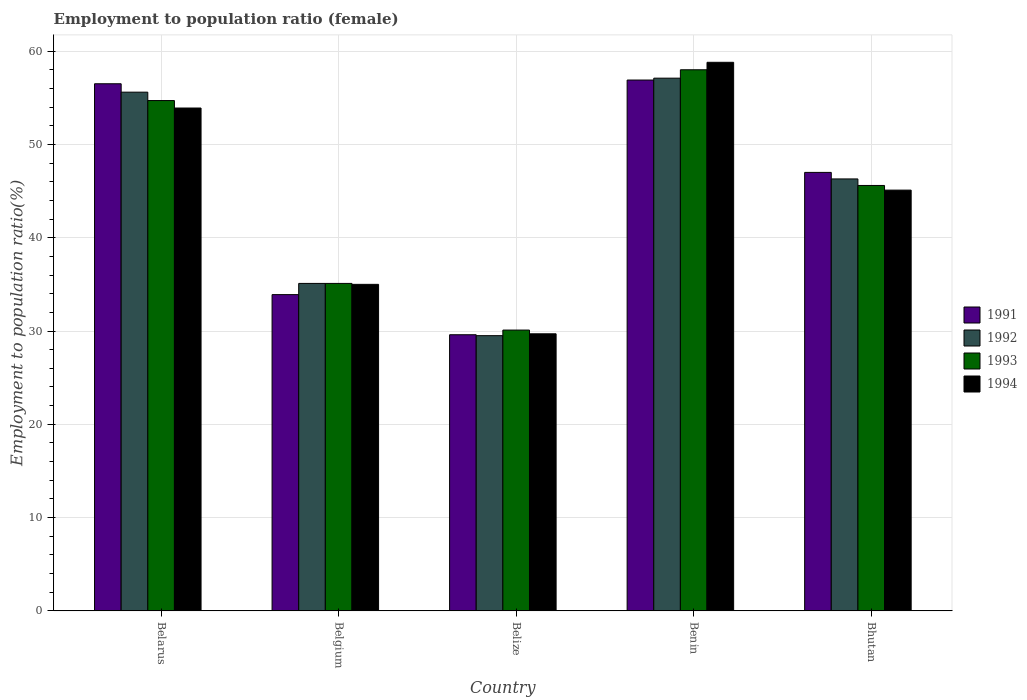How many groups of bars are there?
Offer a terse response. 5. How many bars are there on the 4th tick from the right?
Your answer should be compact. 4. What is the label of the 3rd group of bars from the left?
Provide a short and direct response. Belize. What is the employment to population ratio in 1992 in Belarus?
Ensure brevity in your answer.  55.6. Across all countries, what is the maximum employment to population ratio in 1994?
Offer a terse response. 58.8. Across all countries, what is the minimum employment to population ratio in 1992?
Your answer should be compact. 29.5. In which country was the employment to population ratio in 1991 maximum?
Give a very brief answer. Benin. In which country was the employment to population ratio in 1991 minimum?
Your answer should be compact. Belize. What is the total employment to population ratio in 1993 in the graph?
Offer a very short reply. 223.5. What is the difference between the employment to population ratio in 1992 in Belize and that in Bhutan?
Offer a terse response. -16.8. What is the difference between the employment to population ratio in 1993 in Belize and the employment to population ratio in 1991 in Bhutan?
Provide a succinct answer. -16.9. What is the average employment to population ratio in 1994 per country?
Your response must be concise. 44.5. What is the difference between the employment to population ratio of/in 1991 and employment to population ratio of/in 1992 in Bhutan?
Offer a terse response. 0.7. In how many countries, is the employment to population ratio in 1993 greater than 28 %?
Provide a short and direct response. 5. What is the ratio of the employment to population ratio in 1991 in Benin to that in Bhutan?
Your response must be concise. 1.21. What is the difference between the highest and the second highest employment to population ratio in 1992?
Ensure brevity in your answer.  10.8. What is the difference between the highest and the lowest employment to population ratio in 1992?
Your answer should be very brief. 27.6. In how many countries, is the employment to population ratio in 1991 greater than the average employment to population ratio in 1991 taken over all countries?
Keep it short and to the point. 3. What does the 1st bar from the left in Benin represents?
Give a very brief answer. 1991. What does the 3rd bar from the right in Belize represents?
Offer a very short reply. 1992. Is it the case that in every country, the sum of the employment to population ratio in 1994 and employment to population ratio in 1992 is greater than the employment to population ratio in 1993?
Offer a terse response. Yes. How many bars are there?
Offer a very short reply. 20. How many countries are there in the graph?
Keep it short and to the point. 5. What is the difference between two consecutive major ticks on the Y-axis?
Give a very brief answer. 10. Are the values on the major ticks of Y-axis written in scientific E-notation?
Your answer should be very brief. No. Does the graph contain any zero values?
Offer a terse response. No. How are the legend labels stacked?
Provide a short and direct response. Vertical. What is the title of the graph?
Your answer should be compact. Employment to population ratio (female). What is the label or title of the X-axis?
Give a very brief answer. Country. What is the Employment to population ratio(%) of 1991 in Belarus?
Your response must be concise. 56.5. What is the Employment to population ratio(%) in 1992 in Belarus?
Provide a succinct answer. 55.6. What is the Employment to population ratio(%) in 1993 in Belarus?
Your response must be concise. 54.7. What is the Employment to population ratio(%) in 1994 in Belarus?
Your response must be concise. 53.9. What is the Employment to population ratio(%) of 1991 in Belgium?
Give a very brief answer. 33.9. What is the Employment to population ratio(%) in 1992 in Belgium?
Offer a terse response. 35.1. What is the Employment to population ratio(%) of 1993 in Belgium?
Your answer should be compact. 35.1. What is the Employment to population ratio(%) of 1991 in Belize?
Give a very brief answer. 29.6. What is the Employment to population ratio(%) in 1992 in Belize?
Your answer should be compact. 29.5. What is the Employment to population ratio(%) in 1993 in Belize?
Provide a succinct answer. 30.1. What is the Employment to population ratio(%) in 1994 in Belize?
Keep it short and to the point. 29.7. What is the Employment to population ratio(%) in 1991 in Benin?
Your response must be concise. 56.9. What is the Employment to population ratio(%) of 1992 in Benin?
Your answer should be compact. 57.1. What is the Employment to population ratio(%) of 1994 in Benin?
Give a very brief answer. 58.8. What is the Employment to population ratio(%) of 1991 in Bhutan?
Offer a terse response. 47. What is the Employment to population ratio(%) in 1992 in Bhutan?
Make the answer very short. 46.3. What is the Employment to population ratio(%) in 1993 in Bhutan?
Give a very brief answer. 45.6. What is the Employment to population ratio(%) in 1994 in Bhutan?
Provide a succinct answer. 45.1. Across all countries, what is the maximum Employment to population ratio(%) in 1991?
Offer a terse response. 56.9. Across all countries, what is the maximum Employment to population ratio(%) in 1992?
Give a very brief answer. 57.1. Across all countries, what is the maximum Employment to population ratio(%) in 1994?
Your answer should be compact. 58.8. Across all countries, what is the minimum Employment to population ratio(%) in 1991?
Give a very brief answer. 29.6. Across all countries, what is the minimum Employment to population ratio(%) in 1992?
Offer a very short reply. 29.5. Across all countries, what is the minimum Employment to population ratio(%) of 1993?
Give a very brief answer. 30.1. Across all countries, what is the minimum Employment to population ratio(%) of 1994?
Your answer should be very brief. 29.7. What is the total Employment to population ratio(%) in 1991 in the graph?
Make the answer very short. 223.9. What is the total Employment to population ratio(%) of 1992 in the graph?
Provide a short and direct response. 223.6. What is the total Employment to population ratio(%) of 1993 in the graph?
Offer a very short reply. 223.5. What is the total Employment to population ratio(%) of 1994 in the graph?
Provide a succinct answer. 222.5. What is the difference between the Employment to population ratio(%) in 1991 in Belarus and that in Belgium?
Offer a very short reply. 22.6. What is the difference between the Employment to population ratio(%) of 1993 in Belarus and that in Belgium?
Keep it short and to the point. 19.6. What is the difference between the Employment to population ratio(%) of 1994 in Belarus and that in Belgium?
Keep it short and to the point. 18.9. What is the difference between the Employment to population ratio(%) in 1991 in Belarus and that in Belize?
Provide a succinct answer. 26.9. What is the difference between the Employment to population ratio(%) in 1992 in Belarus and that in Belize?
Ensure brevity in your answer.  26.1. What is the difference between the Employment to population ratio(%) of 1993 in Belarus and that in Belize?
Your answer should be compact. 24.6. What is the difference between the Employment to population ratio(%) in 1994 in Belarus and that in Belize?
Your answer should be compact. 24.2. What is the difference between the Employment to population ratio(%) in 1992 in Belarus and that in Benin?
Your answer should be very brief. -1.5. What is the difference between the Employment to population ratio(%) of 1992 in Belarus and that in Bhutan?
Ensure brevity in your answer.  9.3. What is the difference between the Employment to population ratio(%) of 1993 in Belarus and that in Bhutan?
Offer a very short reply. 9.1. What is the difference between the Employment to population ratio(%) in 1994 in Belarus and that in Bhutan?
Your answer should be very brief. 8.8. What is the difference between the Employment to population ratio(%) in 1991 in Belgium and that in Belize?
Give a very brief answer. 4.3. What is the difference between the Employment to population ratio(%) of 1992 in Belgium and that in Belize?
Provide a succinct answer. 5.6. What is the difference between the Employment to population ratio(%) of 1993 in Belgium and that in Belize?
Your response must be concise. 5. What is the difference between the Employment to population ratio(%) in 1994 in Belgium and that in Belize?
Your answer should be compact. 5.3. What is the difference between the Employment to population ratio(%) of 1992 in Belgium and that in Benin?
Offer a terse response. -22. What is the difference between the Employment to population ratio(%) of 1993 in Belgium and that in Benin?
Keep it short and to the point. -22.9. What is the difference between the Employment to population ratio(%) of 1994 in Belgium and that in Benin?
Keep it short and to the point. -23.8. What is the difference between the Employment to population ratio(%) of 1992 in Belgium and that in Bhutan?
Provide a succinct answer. -11.2. What is the difference between the Employment to population ratio(%) in 1993 in Belgium and that in Bhutan?
Your answer should be compact. -10.5. What is the difference between the Employment to population ratio(%) of 1994 in Belgium and that in Bhutan?
Your answer should be compact. -10.1. What is the difference between the Employment to population ratio(%) in 1991 in Belize and that in Benin?
Keep it short and to the point. -27.3. What is the difference between the Employment to population ratio(%) in 1992 in Belize and that in Benin?
Offer a very short reply. -27.6. What is the difference between the Employment to population ratio(%) in 1993 in Belize and that in Benin?
Make the answer very short. -27.9. What is the difference between the Employment to population ratio(%) of 1994 in Belize and that in Benin?
Your answer should be compact. -29.1. What is the difference between the Employment to population ratio(%) of 1991 in Belize and that in Bhutan?
Keep it short and to the point. -17.4. What is the difference between the Employment to population ratio(%) in 1992 in Belize and that in Bhutan?
Offer a terse response. -16.8. What is the difference between the Employment to population ratio(%) of 1993 in Belize and that in Bhutan?
Your response must be concise. -15.5. What is the difference between the Employment to population ratio(%) of 1994 in Belize and that in Bhutan?
Give a very brief answer. -15.4. What is the difference between the Employment to population ratio(%) in 1991 in Belarus and the Employment to population ratio(%) in 1992 in Belgium?
Provide a short and direct response. 21.4. What is the difference between the Employment to population ratio(%) of 1991 in Belarus and the Employment to population ratio(%) of 1993 in Belgium?
Ensure brevity in your answer.  21.4. What is the difference between the Employment to population ratio(%) of 1992 in Belarus and the Employment to population ratio(%) of 1994 in Belgium?
Offer a very short reply. 20.6. What is the difference between the Employment to population ratio(%) in 1993 in Belarus and the Employment to population ratio(%) in 1994 in Belgium?
Provide a succinct answer. 19.7. What is the difference between the Employment to population ratio(%) of 1991 in Belarus and the Employment to population ratio(%) of 1993 in Belize?
Provide a short and direct response. 26.4. What is the difference between the Employment to population ratio(%) of 1991 in Belarus and the Employment to population ratio(%) of 1994 in Belize?
Offer a very short reply. 26.8. What is the difference between the Employment to population ratio(%) of 1992 in Belarus and the Employment to population ratio(%) of 1994 in Belize?
Provide a short and direct response. 25.9. What is the difference between the Employment to population ratio(%) of 1993 in Belarus and the Employment to population ratio(%) of 1994 in Belize?
Give a very brief answer. 25. What is the difference between the Employment to population ratio(%) of 1991 in Belarus and the Employment to population ratio(%) of 1993 in Benin?
Make the answer very short. -1.5. What is the difference between the Employment to population ratio(%) in 1991 in Belarus and the Employment to population ratio(%) in 1994 in Benin?
Your answer should be very brief. -2.3. What is the difference between the Employment to population ratio(%) of 1992 in Belarus and the Employment to population ratio(%) of 1993 in Benin?
Provide a short and direct response. -2.4. What is the difference between the Employment to population ratio(%) in 1992 in Belarus and the Employment to population ratio(%) in 1994 in Benin?
Provide a succinct answer. -3.2. What is the difference between the Employment to population ratio(%) in 1993 in Belarus and the Employment to population ratio(%) in 1994 in Benin?
Provide a succinct answer. -4.1. What is the difference between the Employment to population ratio(%) of 1991 in Belarus and the Employment to population ratio(%) of 1993 in Bhutan?
Your answer should be very brief. 10.9. What is the difference between the Employment to population ratio(%) in 1991 in Belarus and the Employment to population ratio(%) in 1994 in Bhutan?
Your answer should be compact. 11.4. What is the difference between the Employment to population ratio(%) of 1992 in Belarus and the Employment to population ratio(%) of 1994 in Bhutan?
Your answer should be very brief. 10.5. What is the difference between the Employment to population ratio(%) in 1991 in Belgium and the Employment to population ratio(%) in 1993 in Belize?
Provide a succinct answer. 3.8. What is the difference between the Employment to population ratio(%) in 1992 in Belgium and the Employment to population ratio(%) in 1994 in Belize?
Give a very brief answer. 5.4. What is the difference between the Employment to population ratio(%) in 1993 in Belgium and the Employment to population ratio(%) in 1994 in Belize?
Keep it short and to the point. 5.4. What is the difference between the Employment to population ratio(%) in 1991 in Belgium and the Employment to population ratio(%) in 1992 in Benin?
Make the answer very short. -23.2. What is the difference between the Employment to population ratio(%) of 1991 in Belgium and the Employment to population ratio(%) of 1993 in Benin?
Give a very brief answer. -24.1. What is the difference between the Employment to population ratio(%) in 1991 in Belgium and the Employment to population ratio(%) in 1994 in Benin?
Ensure brevity in your answer.  -24.9. What is the difference between the Employment to population ratio(%) of 1992 in Belgium and the Employment to population ratio(%) of 1993 in Benin?
Your answer should be compact. -22.9. What is the difference between the Employment to population ratio(%) of 1992 in Belgium and the Employment to population ratio(%) of 1994 in Benin?
Give a very brief answer. -23.7. What is the difference between the Employment to population ratio(%) in 1993 in Belgium and the Employment to population ratio(%) in 1994 in Benin?
Make the answer very short. -23.7. What is the difference between the Employment to population ratio(%) in 1991 in Belgium and the Employment to population ratio(%) in 1992 in Bhutan?
Ensure brevity in your answer.  -12.4. What is the difference between the Employment to population ratio(%) in 1991 in Belgium and the Employment to population ratio(%) in 1994 in Bhutan?
Ensure brevity in your answer.  -11.2. What is the difference between the Employment to population ratio(%) of 1991 in Belize and the Employment to population ratio(%) of 1992 in Benin?
Make the answer very short. -27.5. What is the difference between the Employment to population ratio(%) in 1991 in Belize and the Employment to population ratio(%) in 1993 in Benin?
Provide a short and direct response. -28.4. What is the difference between the Employment to population ratio(%) of 1991 in Belize and the Employment to population ratio(%) of 1994 in Benin?
Keep it short and to the point. -29.2. What is the difference between the Employment to population ratio(%) in 1992 in Belize and the Employment to population ratio(%) in 1993 in Benin?
Make the answer very short. -28.5. What is the difference between the Employment to population ratio(%) of 1992 in Belize and the Employment to population ratio(%) of 1994 in Benin?
Your response must be concise. -29.3. What is the difference between the Employment to population ratio(%) in 1993 in Belize and the Employment to population ratio(%) in 1994 in Benin?
Provide a short and direct response. -28.7. What is the difference between the Employment to population ratio(%) of 1991 in Belize and the Employment to population ratio(%) of 1992 in Bhutan?
Ensure brevity in your answer.  -16.7. What is the difference between the Employment to population ratio(%) of 1991 in Belize and the Employment to population ratio(%) of 1994 in Bhutan?
Provide a succinct answer. -15.5. What is the difference between the Employment to population ratio(%) of 1992 in Belize and the Employment to population ratio(%) of 1993 in Bhutan?
Your answer should be very brief. -16.1. What is the difference between the Employment to population ratio(%) in 1992 in Belize and the Employment to population ratio(%) in 1994 in Bhutan?
Give a very brief answer. -15.6. What is the difference between the Employment to population ratio(%) in 1993 in Belize and the Employment to population ratio(%) in 1994 in Bhutan?
Make the answer very short. -15. What is the difference between the Employment to population ratio(%) of 1991 in Benin and the Employment to population ratio(%) of 1993 in Bhutan?
Provide a succinct answer. 11.3. What is the difference between the Employment to population ratio(%) in 1991 in Benin and the Employment to population ratio(%) in 1994 in Bhutan?
Your answer should be compact. 11.8. What is the difference between the Employment to population ratio(%) in 1992 in Benin and the Employment to population ratio(%) in 1993 in Bhutan?
Ensure brevity in your answer.  11.5. What is the difference between the Employment to population ratio(%) of 1992 in Benin and the Employment to population ratio(%) of 1994 in Bhutan?
Provide a short and direct response. 12. What is the difference between the Employment to population ratio(%) in 1993 in Benin and the Employment to population ratio(%) in 1994 in Bhutan?
Your answer should be compact. 12.9. What is the average Employment to population ratio(%) of 1991 per country?
Provide a short and direct response. 44.78. What is the average Employment to population ratio(%) of 1992 per country?
Provide a short and direct response. 44.72. What is the average Employment to population ratio(%) of 1993 per country?
Provide a succinct answer. 44.7. What is the average Employment to population ratio(%) of 1994 per country?
Provide a succinct answer. 44.5. What is the difference between the Employment to population ratio(%) of 1991 and Employment to population ratio(%) of 1992 in Belarus?
Your answer should be compact. 0.9. What is the difference between the Employment to population ratio(%) in 1991 and Employment to population ratio(%) in 1993 in Belarus?
Keep it short and to the point. 1.8. What is the difference between the Employment to population ratio(%) in 1991 and Employment to population ratio(%) in 1994 in Belarus?
Make the answer very short. 2.6. What is the difference between the Employment to population ratio(%) in 1992 and Employment to population ratio(%) in 1993 in Belarus?
Provide a short and direct response. 0.9. What is the difference between the Employment to population ratio(%) in 1991 and Employment to population ratio(%) in 1993 in Belgium?
Provide a succinct answer. -1.2. What is the difference between the Employment to population ratio(%) in 1991 and Employment to population ratio(%) in 1993 in Belize?
Your answer should be compact. -0.5. What is the difference between the Employment to population ratio(%) of 1991 and Employment to population ratio(%) of 1994 in Belize?
Offer a very short reply. -0.1. What is the difference between the Employment to population ratio(%) in 1992 and Employment to population ratio(%) in 1993 in Belize?
Your response must be concise. -0.6. What is the difference between the Employment to population ratio(%) in 1993 and Employment to population ratio(%) in 1994 in Belize?
Keep it short and to the point. 0.4. What is the difference between the Employment to population ratio(%) in 1991 and Employment to population ratio(%) in 1992 in Benin?
Keep it short and to the point. -0.2. What is the difference between the Employment to population ratio(%) in 1991 and Employment to population ratio(%) in 1994 in Benin?
Offer a terse response. -1.9. What is the difference between the Employment to population ratio(%) of 1992 and Employment to population ratio(%) of 1993 in Benin?
Offer a terse response. -0.9. What is the difference between the Employment to population ratio(%) in 1992 and Employment to population ratio(%) in 1994 in Benin?
Your answer should be compact. -1.7. What is the difference between the Employment to population ratio(%) of 1991 and Employment to population ratio(%) of 1993 in Bhutan?
Give a very brief answer. 1.4. What is the difference between the Employment to population ratio(%) of 1992 and Employment to population ratio(%) of 1993 in Bhutan?
Offer a very short reply. 0.7. What is the difference between the Employment to population ratio(%) of 1992 and Employment to population ratio(%) of 1994 in Bhutan?
Offer a very short reply. 1.2. What is the difference between the Employment to population ratio(%) of 1993 and Employment to population ratio(%) of 1994 in Bhutan?
Provide a short and direct response. 0.5. What is the ratio of the Employment to population ratio(%) of 1992 in Belarus to that in Belgium?
Keep it short and to the point. 1.58. What is the ratio of the Employment to population ratio(%) of 1993 in Belarus to that in Belgium?
Your answer should be very brief. 1.56. What is the ratio of the Employment to population ratio(%) of 1994 in Belarus to that in Belgium?
Make the answer very short. 1.54. What is the ratio of the Employment to population ratio(%) of 1991 in Belarus to that in Belize?
Your answer should be compact. 1.91. What is the ratio of the Employment to population ratio(%) of 1992 in Belarus to that in Belize?
Your answer should be compact. 1.88. What is the ratio of the Employment to population ratio(%) in 1993 in Belarus to that in Belize?
Your response must be concise. 1.82. What is the ratio of the Employment to population ratio(%) in 1994 in Belarus to that in Belize?
Offer a terse response. 1.81. What is the ratio of the Employment to population ratio(%) of 1992 in Belarus to that in Benin?
Give a very brief answer. 0.97. What is the ratio of the Employment to population ratio(%) in 1993 in Belarus to that in Benin?
Your response must be concise. 0.94. What is the ratio of the Employment to population ratio(%) of 1994 in Belarus to that in Benin?
Ensure brevity in your answer.  0.92. What is the ratio of the Employment to population ratio(%) in 1991 in Belarus to that in Bhutan?
Your answer should be compact. 1.2. What is the ratio of the Employment to population ratio(%) in 1992 in Belarus to that in Bhutan?
Ensure brevity in your answer.  1.2. What is the ratio of the Employment to population ratio(%) in 1993 in Belarus to that in Bhutan?
Offer a very short reply. 1.2. What is the ratio of the Employment to population ratio(%) of 1994 in Belarus to that in Bhutan?
Ensure brevity in your answer.  1.2. What is the ratio of the Employment to population ratio(%) of 1991 in Belgium to that in Belize?
Ensure brevity in your answer.  1.15. What is the ratio of the Employment to population ratio(%) of 1992 in Belgium to that in Belize?
Make the answer very short. 1.19. What is the ratio of the Employment to population ratio(%) of 1993 in Belgium to that in Belize?
Give a very brief answer. 1.17. What is the ratio of the Employment to population ratio(%) in 1994 in Belgium to that in Belize?
Make the answer very short. 1.18. What is the ratio of the Employment to population ratio(%) of 1991 in Belgium to that in Benin?
Make the answer very short. 0.6. What is the ratio of the Employment to population ratio(%) in 1992 in Belgium to that in Benin?
Your response must be concise. 0.61. What is the ratio of the Employment to population ratio(%) of 1993 in Belgium to that in Benin?
Ensure brevity in your answer.  0.61. What is the ratio of the Employment to population ratio(%) in 1994 in Belgium to that in Benin?
Provide a succinct answer. 0.6. What is the ratio of the Employment to population ratio(%) in 1991 in Belgium to that in Bhutan?
Your answer should be compact. 0.72. What is the ratio of the Employment to population ratio(%) in 1992 in Belgium to that in Bhutan?
Provide a succinct answer. 0.76. What is the ratio of the Employment to population ratio(%) of 1993 in Belgium to that in Bhutan?
Your answer should be very brief. 0.77. What is the ratio of the Employment to population ratio(%) of 1994 in Belgium to that in Bhutan?
Your answer should be compact. 0.78. What is the ratio of the Employment to population ratio(%) in 1991 in Belize to that in Benin?
Ensure brevity in your answer.  0.52. What is the ratio of the Employment to population ratio(%) in 1992 in Belize to that in Benin?
Ensure brevity in your answer.  0.52. What is the ratio of the Employment to population ratio(%) in 1993 in Belize to that in Benin?
Your answer should be compact. 0.52. What is the ratio of the Employment to population ratio(%) in 1994 in Belize to that in Benin?
Offer a terse response. 0.51. What is the ratio of the Employment to population ratio(%) in 1991 in Belize to that in Bhutan?
Your answer should be compact. 0.63. What is the ratio of the Employment to population ratio(%) of 1992 in Belize to that in Bhutan?
Your answer should be very brief. 0.64. What is the ratio of the Employment to population ratio(%) of 1993 in Belize to that in Bhutan?
Offer a very short reply. 0.66. What is the ratio of the Employment to population ratio(%) in 1994 in Belize to that in Bhutan?
Provide a succinct answer. 0.66. What is the ratio of the Employment to population ratio(%) of 1991 in Benin to that in Bhutan?
Offer a terse response. 1.21. What is the ratio of the Employment to population ratio(%) in 1992 in Benin to that in Bhutan?
Keep it short and to the point. 1.23. What is the ratio of the Employment to population ratio(%) in 1993 in Benin to that in Bhutan?
Your answer should be very brief. 1.27. What is the ratio of the Employment to population ratio(%) in 1994 in Benin to that in Bhutan?
Ensure brevity in your answer.  1.3. What is the difference between the highest and the second highest Employment to population ratio(%) of 1991?
Provide a short and direct response. 0.4. What is the difference between the highest and the second highest Employment to population ratio(%) in 1992?
Provide a succinct answer. 1.5. What is the difference between the highest and the lowest Employment to population ratio(%) in 1991?
Your answer should be compact. 27.3. What is the difference between the highest and the lowest Employment to population ratio(%) of 1992?
Give a very brief answer. 27.6. What is the difference between the highest and the lowest Employment to population ratio(%) of 1993?
Your answer should be compact. 27.9. What is the difference between the highest and the lowest Employment to population ratio(%) in 1994?
Make the answer very short. 29.1. 